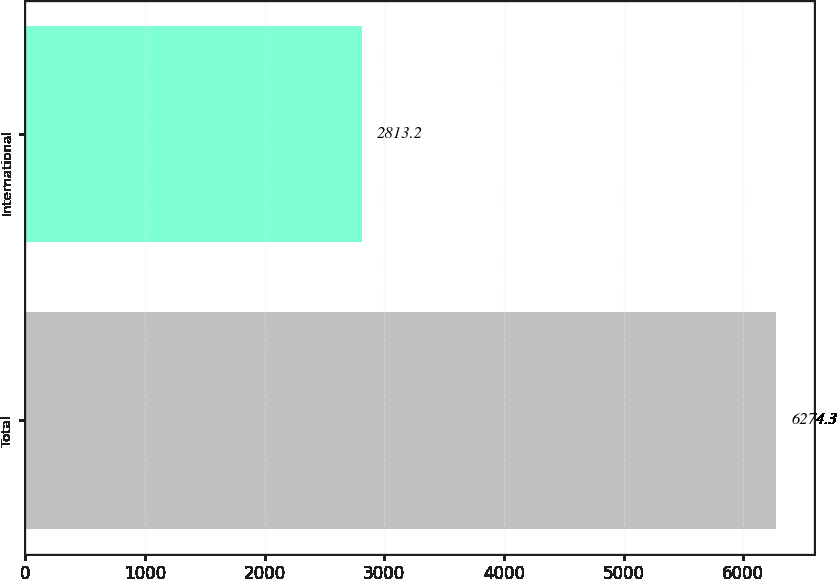Convert chart to OTSL. <chart><loc_0><loc_0><loc_500><loc_500><bar_chart><fcel>Total<fcel>International<nl><fcel>6274.3<fcel>2813.2<nl></chart> 